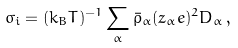Convert formula to latex. <formula><loc_0><loc_0><loc_500><loc_500>\sigma _ { i } = ( k _ { B } T ) ^ { - 1 } \sum _ { \alpha } { \bar { \rho } } _ { \alpha } ( z _ { \alpha } e ) ^ { 2 } D _ { \alpha } \, ,</formula> 